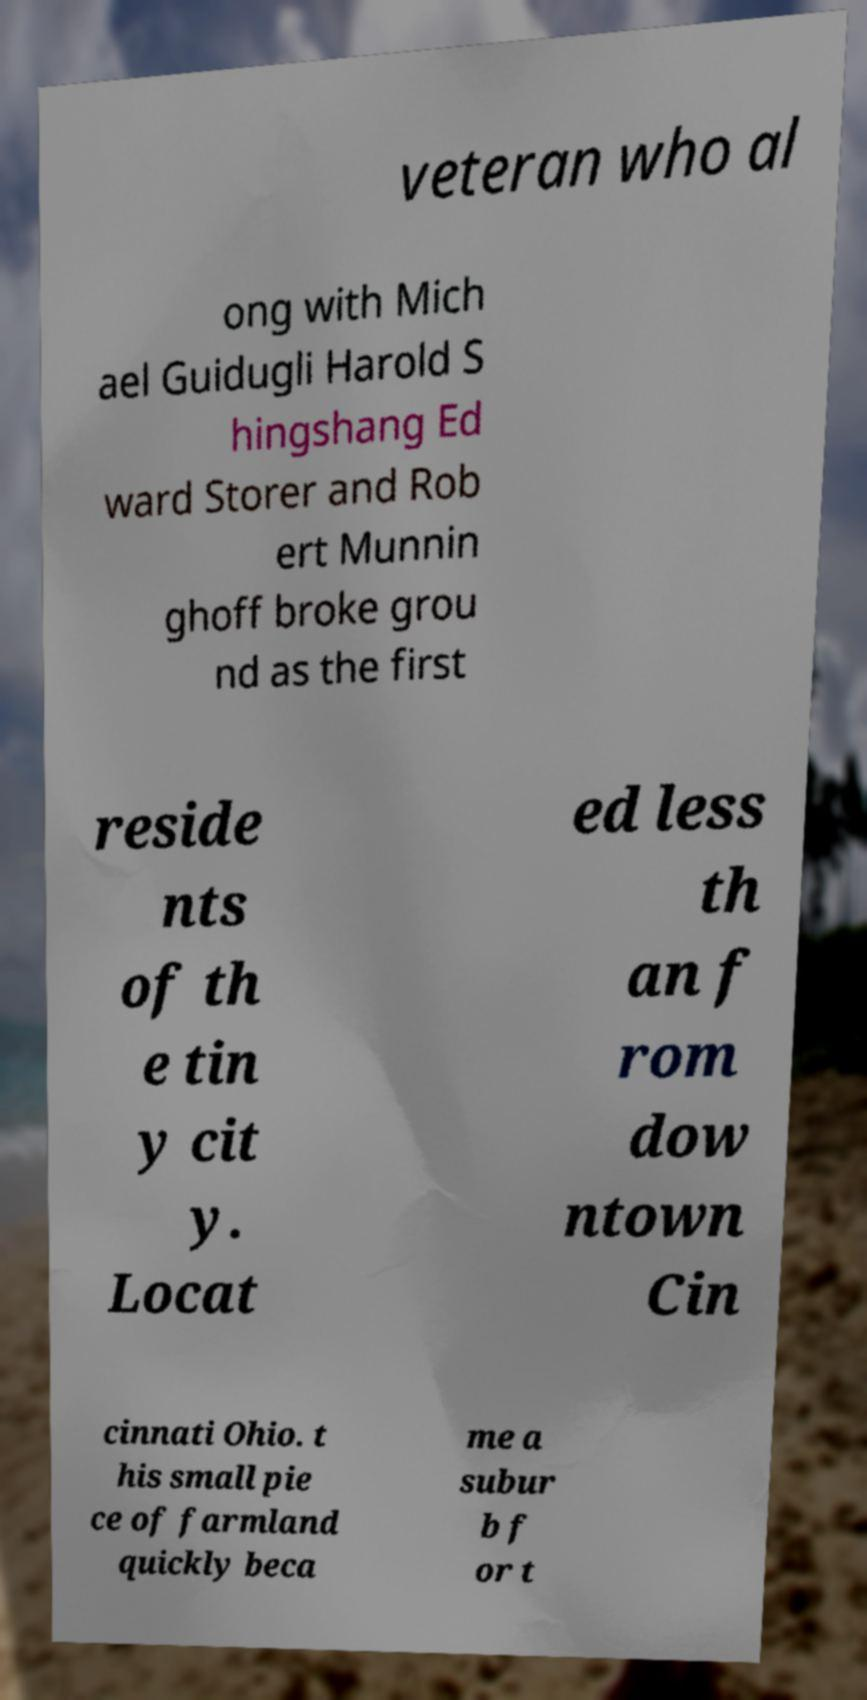There's text embedded in this image that I need extracted. Can you transcribe it verbatim? veteran who al ong with Mich ael Guidugli Harold S hingshang Ed ward Storer and Rob ert Munnin ghoff broke grou nd as the first reside nts of th e tin y cit y. Locat ed less th an f rom dow ntown Cin cinnati Ohio. t his small pie ce of farmland quickly beca me a subur b f or t 